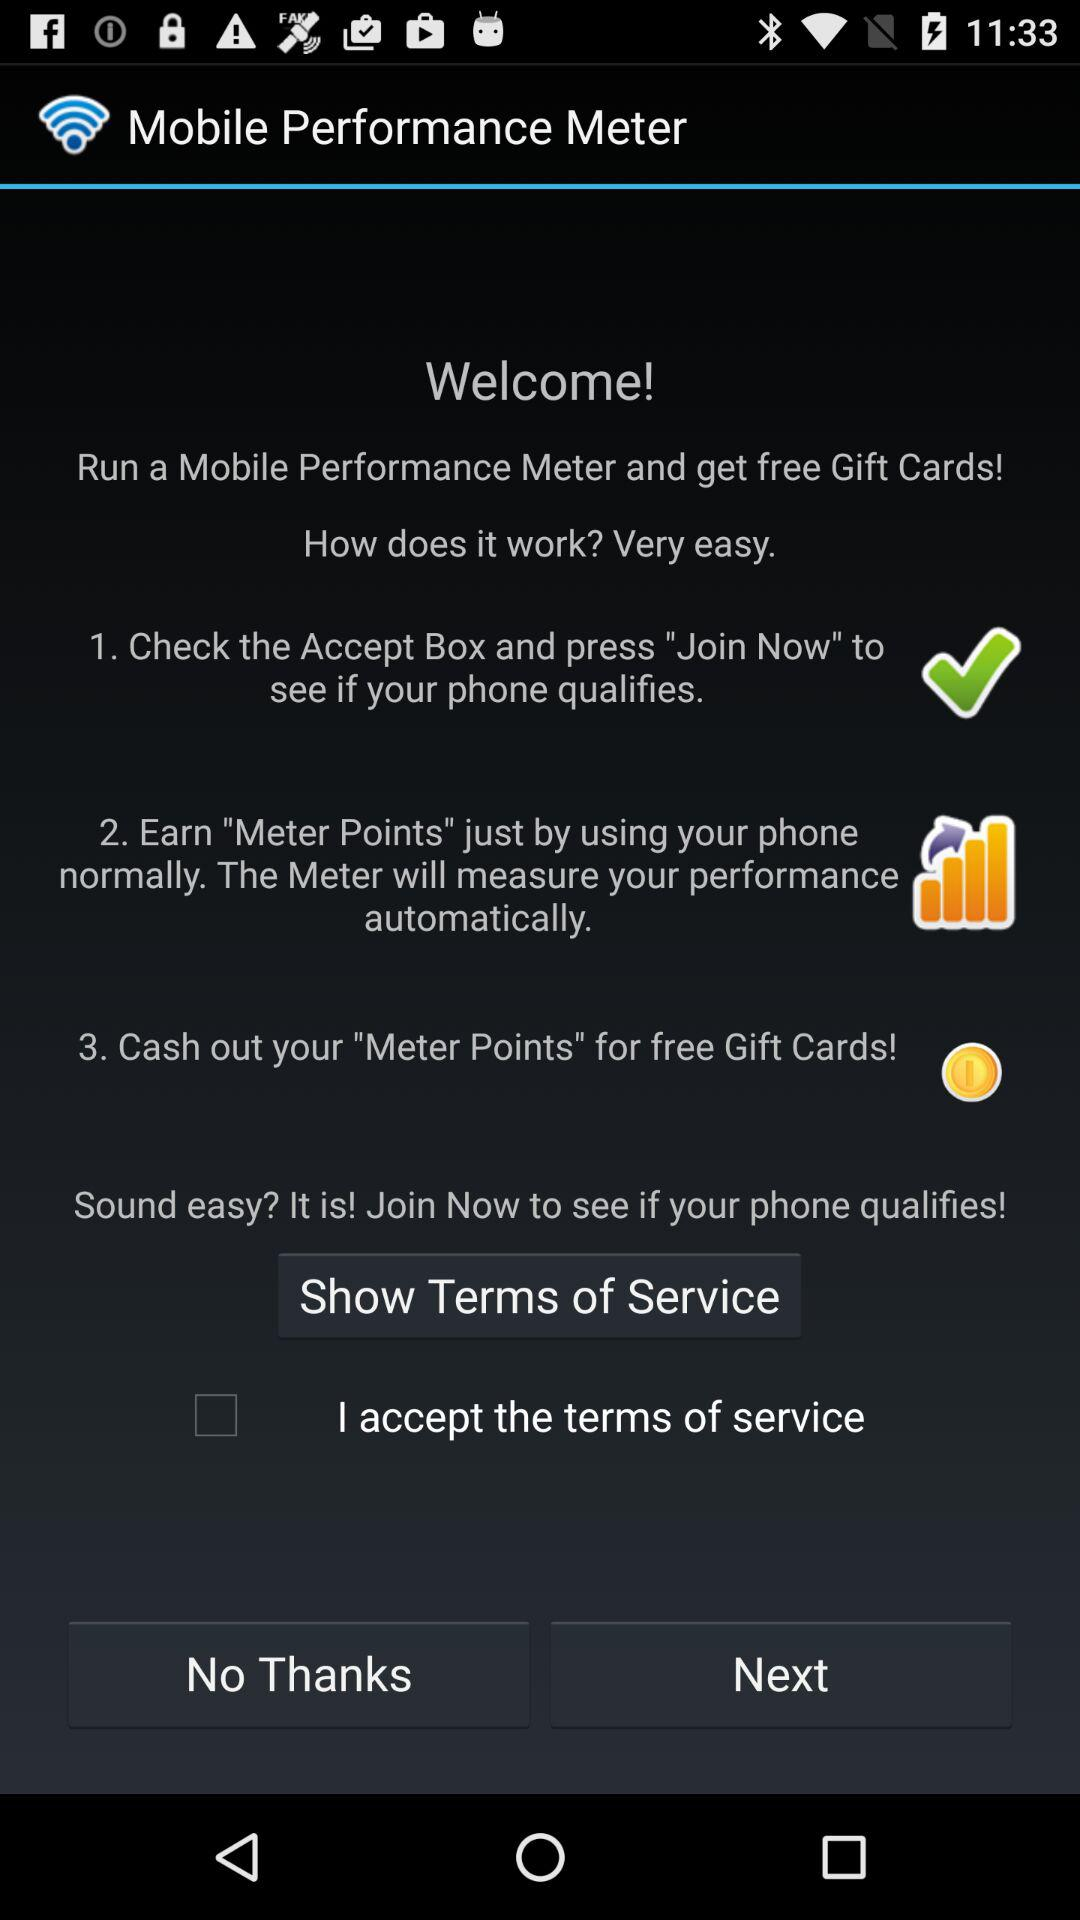How many steps are there in the process of running a Mobile Performance Meter?
Answer the question using a single word or phrase. 3 